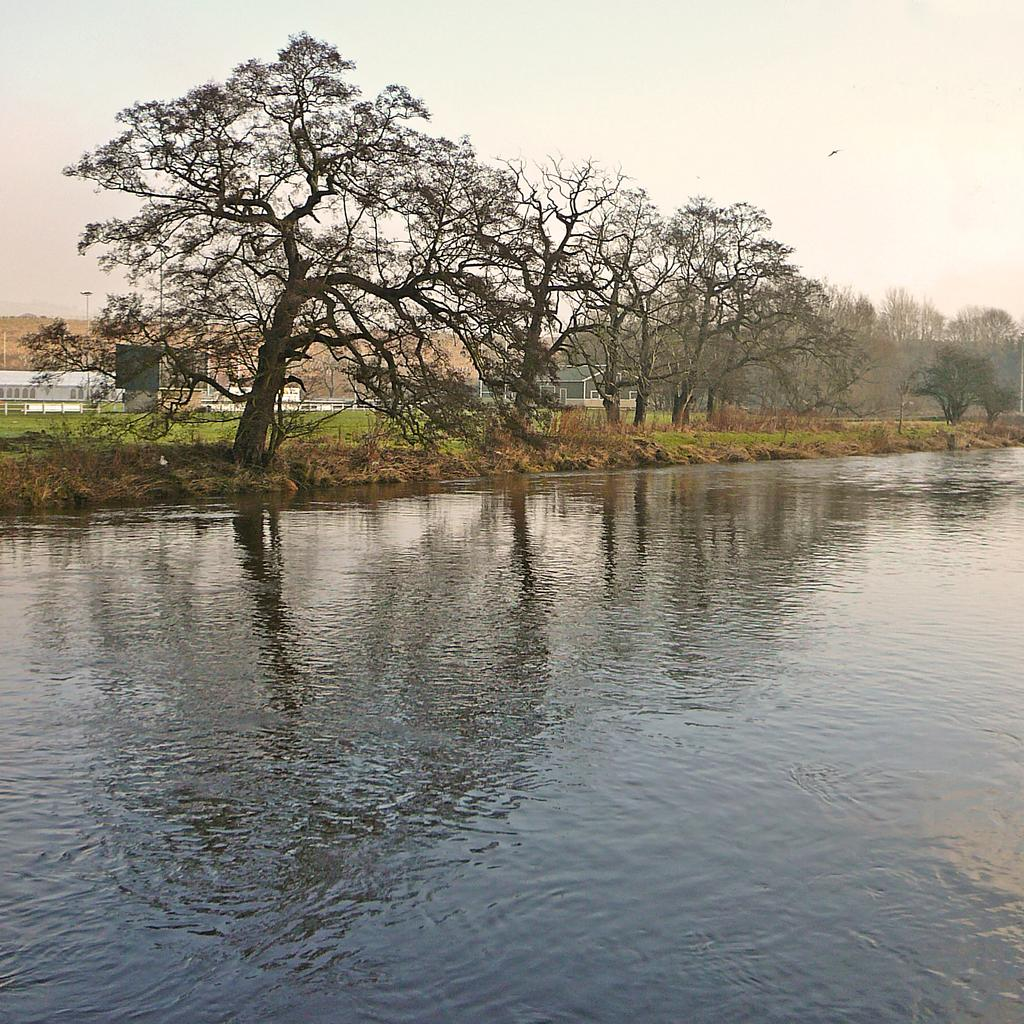What type of setting is depicted in the image? The image is an outside view. What can be seen at the bottom of the image? There is water visible at the bottom of the image. What is visible in the background of the image? There are many trees and houses in the background of the image. What is visible at the top of the image? The sky is visible at the top of the image. What type of pancake is being served in the image? There is no pancake present in the image; it is an outside view with water, trees, houses, and sky. What is the mindset of the trees in the image? The trees in the image do not have a mindset, as they are inanimate objects. 